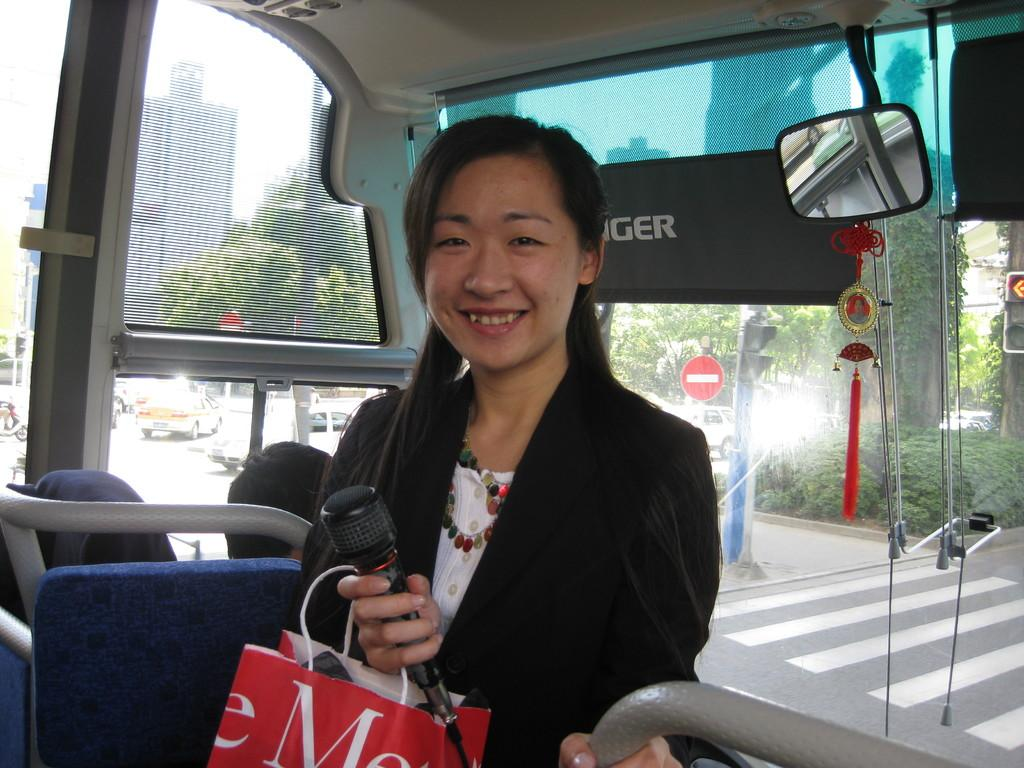What is the woman doing in the bus? The woman is standing in a bus and holding a cover and a mic. What might the woman be using the mic for? The woman might be using the mic for speaking or singing in the bus. What can be seen in the background of the image? There are cars parked on the road and buildings visible in the background. What type of jam is being served to the passengers in the bus? There is no jam present in the image; the woman is holding a cover and a mic. What cause is the woman advocating for in the bus? There is no indication of a cause or protest in the image; the woman is simply holding a cover and a mic. 